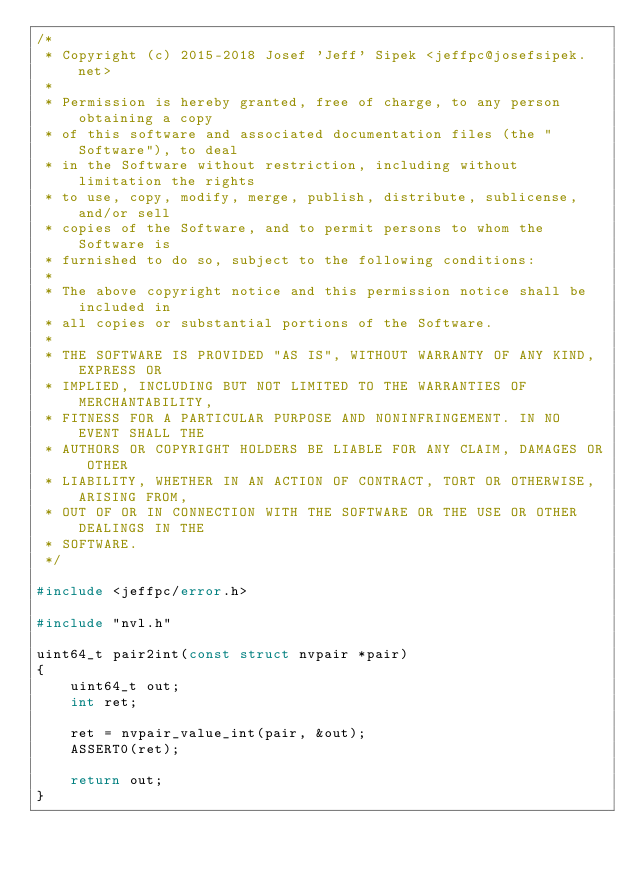<code> <loc_0><loc_0><loc_500><loc_500><_C_>/*
 * Copyright (c) 2015-2018 Josef 'Jeff' Sipek <jeffpc@josefsipek.net>
 *
 * Permission is hereby granted, free of charge, to any person obtaining a copy
 * of this software and associated documentation files (the "Software"), to deal
 * in the Software without restriction, including without limitation the rights
 * to use, copy, modify, merge, publish, distribute, sublicense, and/or sell
 * copies of the Software, and to permit persons to whom the Software is
 * furnished to do so, subject to the following conditions:
 *
 * The above copyright notice and this permission notice shall be included in
 * all copies or substantial portions of the Software.
 *
 * THE SOFTWARE IS PROVIDED "AS IS", WITHOUT WARRANTY OF ANY KIND, EXPRESS OR
 * IMPLIED, INCLUDING BUT NOT LIMITED TO THE WARRANTIES OF MERCHANTABILITY,
 * FITNESS FOR A PARTICULAR PURPOSE AND NONINFRINGEMENT. IN NO EVENT SHALL THE
 * AUTHORS OR COPYRIGHT HOLDERS BE LIABLE FOR ANY CLAIM, DAMAGES OR OTHER
 * LIABILITY, WHETHER IN AN ACTION OF CONTRACT, TORT OR OTHERWISE, ARISING FROM,
 * OUT OF OR IN CONNECTION WITH THE SOFTWARE OR THE USE OR OTHER DEALINGS IN THE
 * SOFTWARE.
 */

#include <jeffpc/error.h>

#include "nvl.h"

uint64_t pair2int(const struct nvpair *pair)
{
	uint64_t out;
	int ret;

	ret = nvpair_value_int(pair, &out);
	ASSERT0(ret);

	return out;
}
</code> 